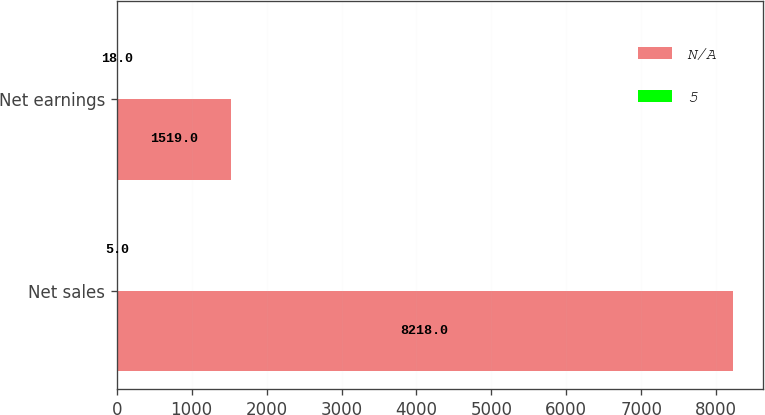Convert chart. <chart><loc_0><loc_0><loc_500><loc_500><stacked_bar_chart><ecel><fcel>Net sales<fcel>Net earnings<nl><fcel>nan<fcel>8218<fcel>1519<nl><fcel>5<fcel>5<fcel>18<nl></chart> 